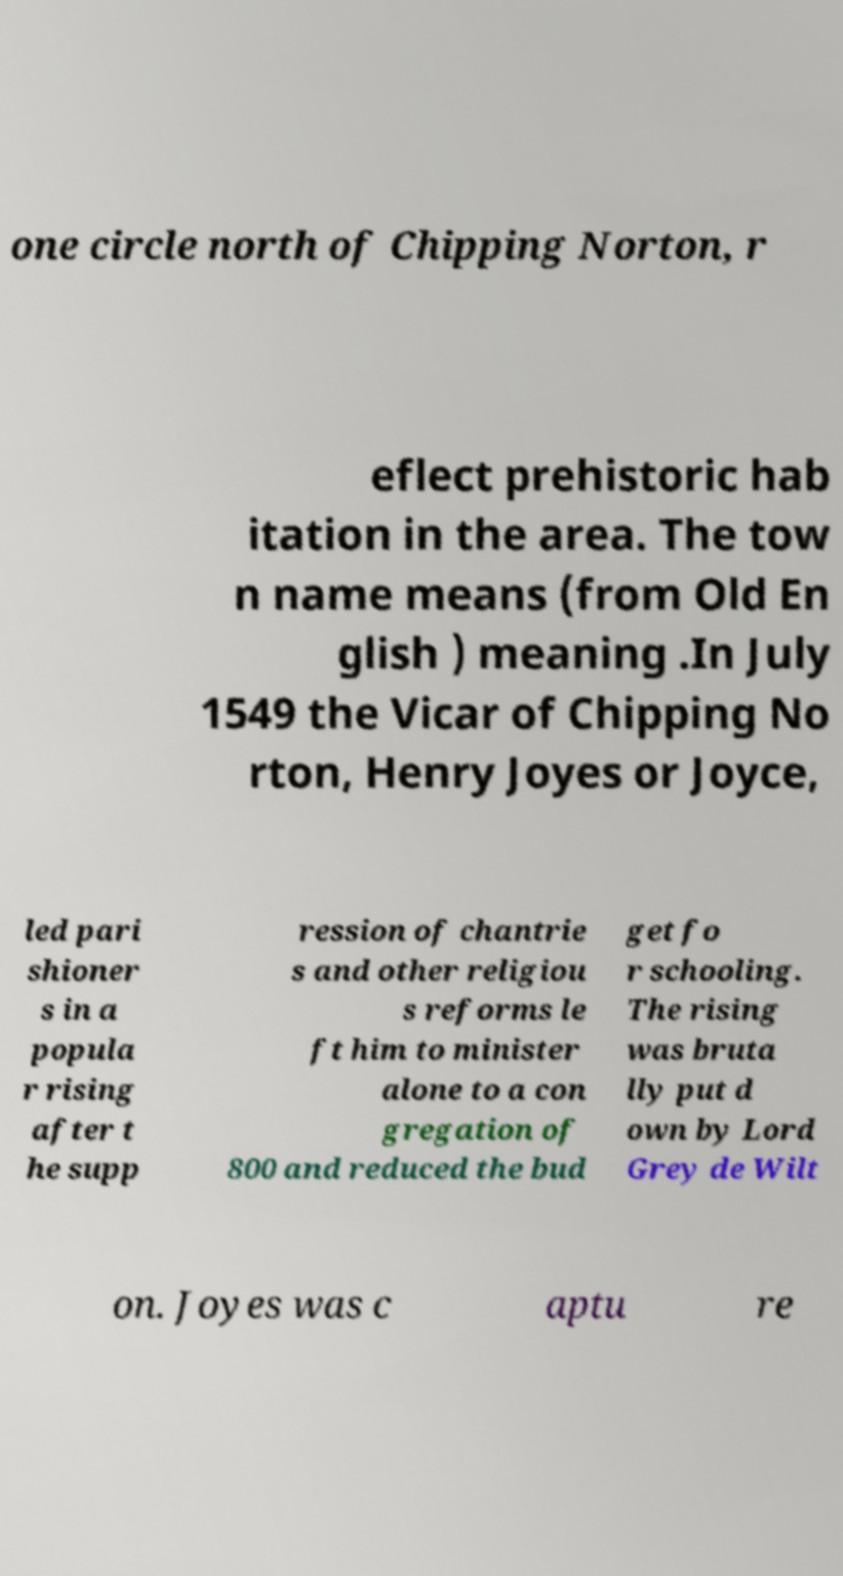For documentation purposes, I need the text within this image transcribed. Could you provide that? one circle north of Chipping Norton, r eflect prehistoric hab itation in the area. The tow n name means (from Old En glish ) meaning .In July 1549 the Vicar of Chipping No rton, Henry Joyes or Joyce, led pari shioner s in a popula r rising after t he supp ression of chantrie s and other religiou s reforms le ft him to minister alone to a con gregation of 800 and reduced the bud get fo r schooling. The rising was bruta lly put d own by Lord Grey de Wilt on. Joyes was c aptu re 